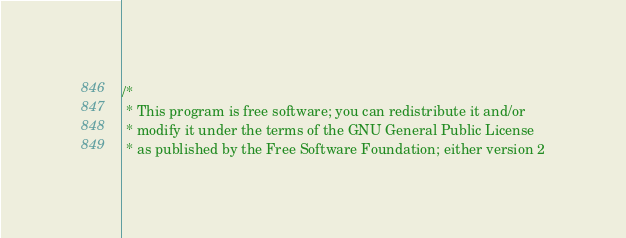Convert code to text. <code><loc_0><loc_0><loc_500><loc_500><_C++_>/*
 * This program is free software; you can redistribute it and/or
 * modify it under the terms of the GNU General Public License
 * as published by the Free Software Foundation; either version 2</code> 